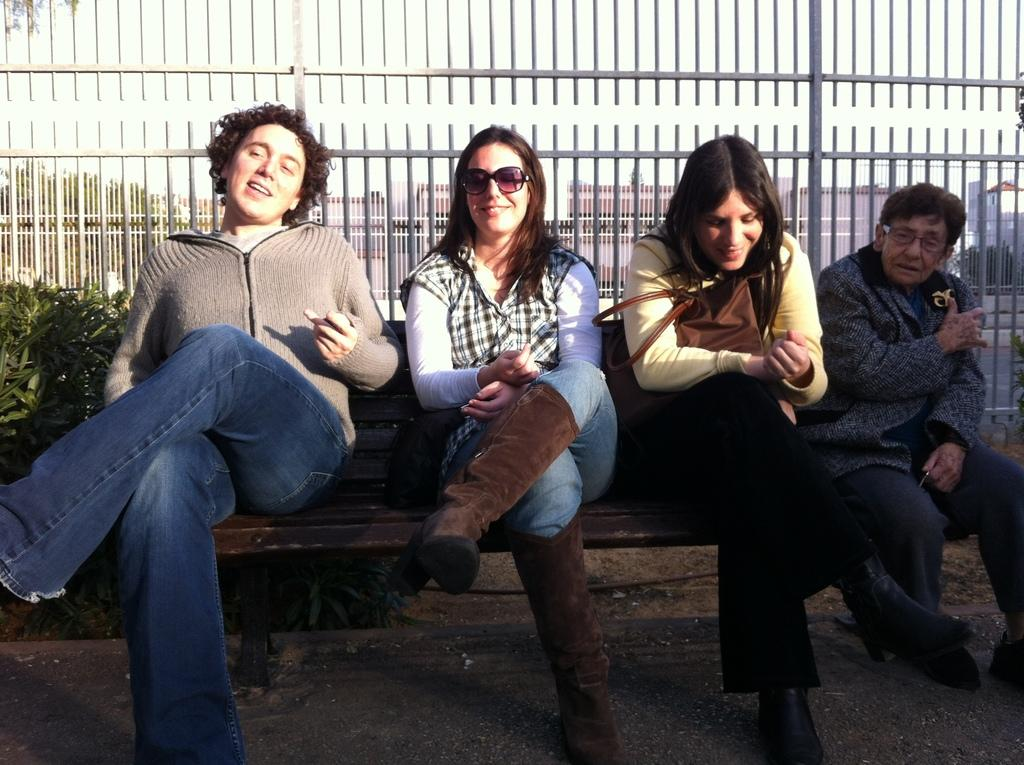How many people are in the group in the image? There is a group of people in the image, but the exact number is not specified. What can be observed about some of the people in the group? Some people in the group are wearing spectacles. Where are the people in the group seated? The people are seated on a bench. What can be seen in the background of the image? In the background, there are plants, metal rods, trees, and buildings. What type of bit is being traded among the people in the image? There is no indication of any bit being traded among the people in the image. What operation is being performed by the people in the image? There is no operation being performed by the people in the image; they are simply seated on a bench. 